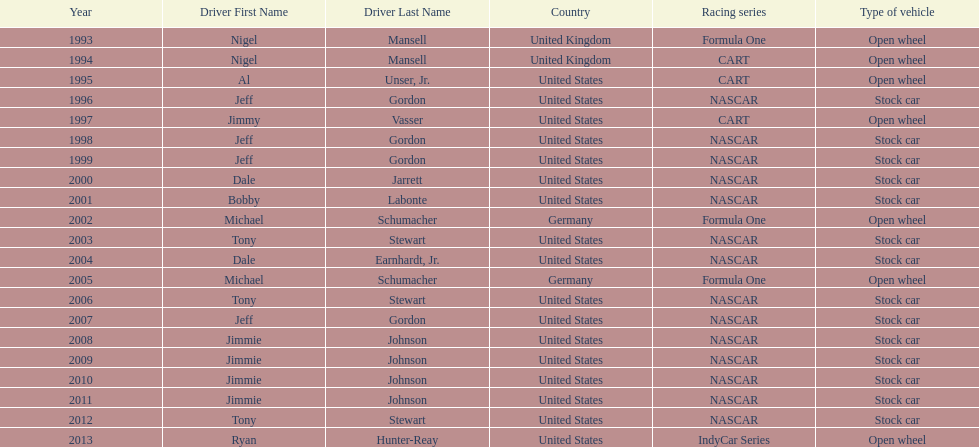Which racing series has the highest total of winners? NASCAR. 